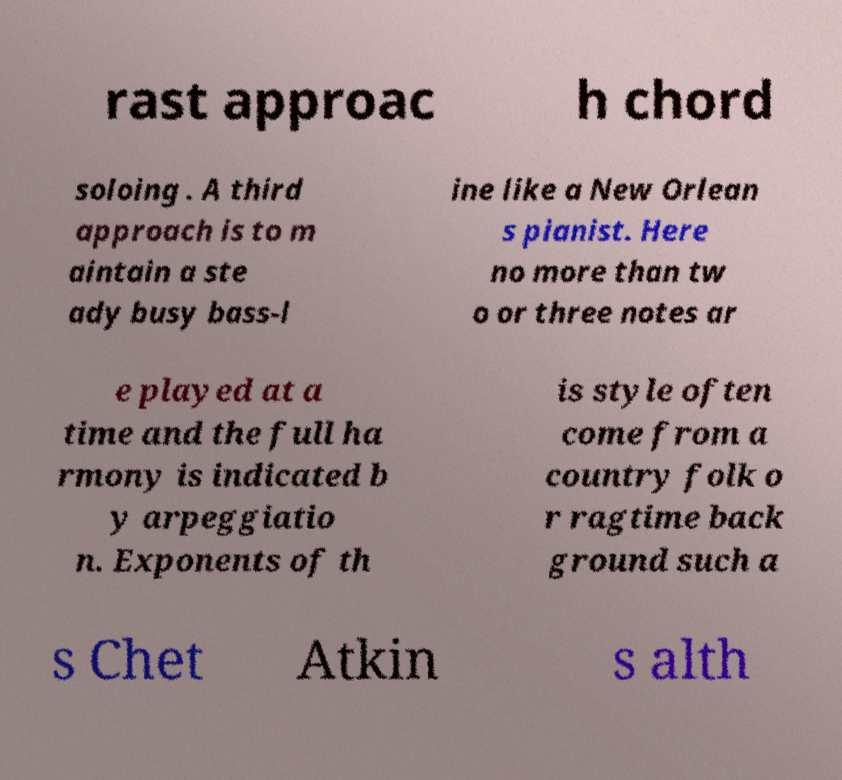There's text embedded in this image that I need extracted. Can you transcribe it verbatim? rast approac h chord soloing . A third approach is to m aintain a ste ady busy bass-l ine like a New Orlean s pianist. Here no more than tw o or three notes ar e played at a time and the full ha rmony is indicated b y arpeggiatio n. Exponents of th is style often come from a country folk o r ragtime back ground such a s Chet Atkin s alth 